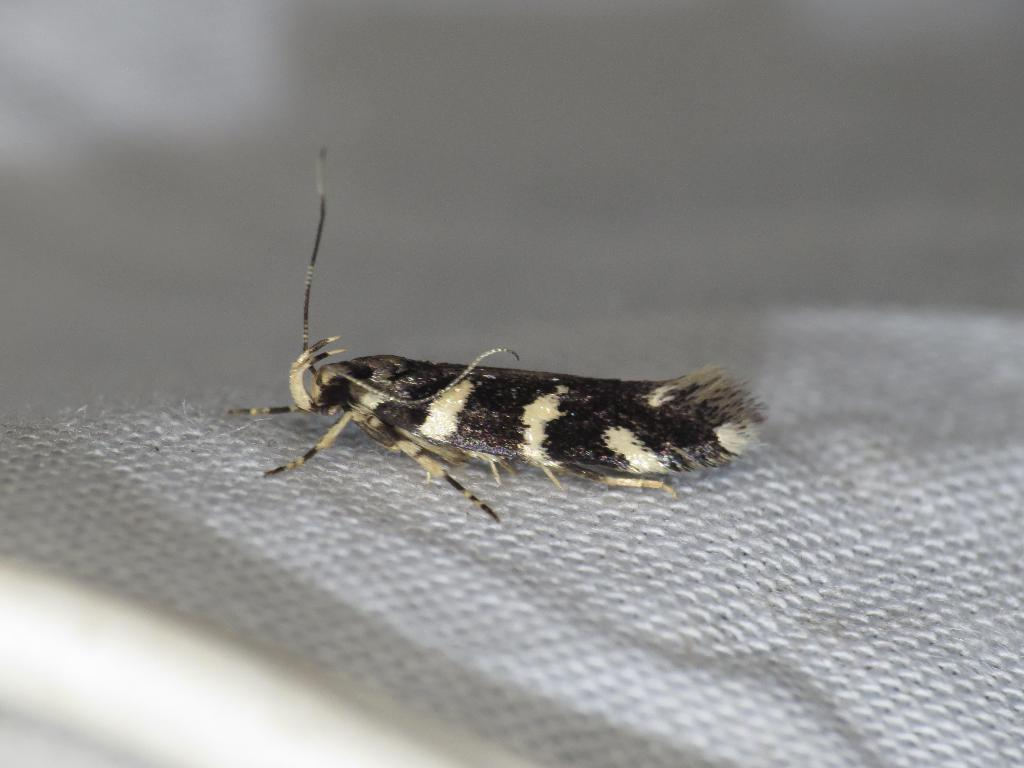What type of living organism can be seen in the image? There is an insect in the image. What type of sweater is the insect wearing in the image? There is no sweater present in the image, as insects do not wear clothing. 